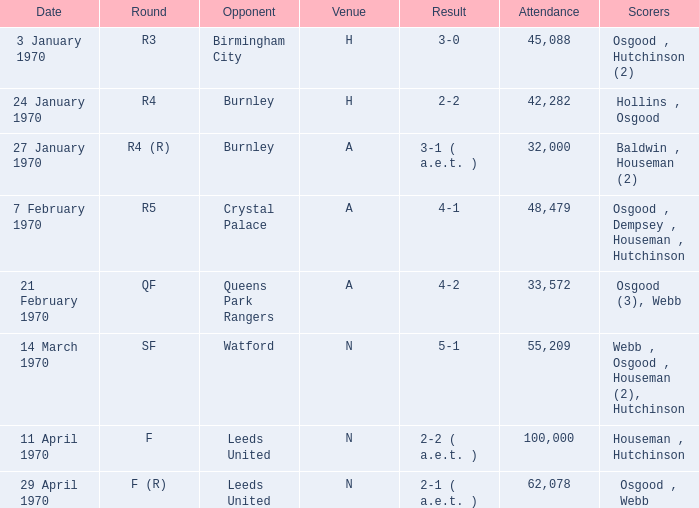What round was the game against Watford? SF. Parse the table in full. {'header': ['Date', 'Round', 'Opponent', 'Venue', 'Result', 'Attendance', 'Scorers'], 'rows': [['3 January 1970', 'R3', 'Birmingham City', 'H', '3-0', '45,088', 'Osgood , Hutchinson (2)'], ['24 January 1970', 'R4', 'Burnley', 'H', '2-2', '42,282', 'Hollins , Osgood'], ['27 January 1970', 'R4 (R)', 'Burnley', 'A', '3-1 ( a.e.t. )', '32,000', 'Baldwin , Houseman (2)'], ['7 February 1970', 'R5', 'Crystal Palace', 'A', '4-1', '48,479', 'Osgood , Dempsey , Houseman , Hutchinson'], ['21 February 1970', 'QF', 'Queens Park Rangers', 'A', '4-2', '33,572', 'Osgood (3), Webb'], ['14 March 1970', 'SF', 'Watford', 'N', '5-1', '55,209', 'Webb , Osgood , Houseman (2), Hutchinson'], ['11 April 1970', 'F', 'Leeds United', 'N', '2-2 ( a.e.t. )', '100,000', 'Houseman , Hutchinson'], ['29 April 1970', 'F (R)', 'Leeds United', 'N', '2-1 ( a.e.t. )', '62,078', 'Osgood , Webb']]} 